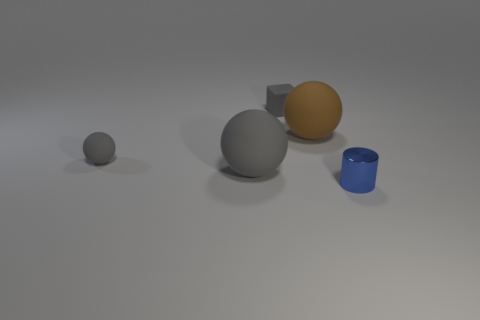Add 5 rubber things. How many objects exist? 10 Subtract all blocks. How many objects are left? 4 Subtract all large brown rubber things. Subtract all small metallic balls. How many objects are left? 4 Add 5 blue cylinders. How many blue cylinders are left? 6 Add 1 tiny brown metallic balls. How many tiny brown metallic balls exist? 1 Subtract 1 gray cubes. How many objects are left? 4 